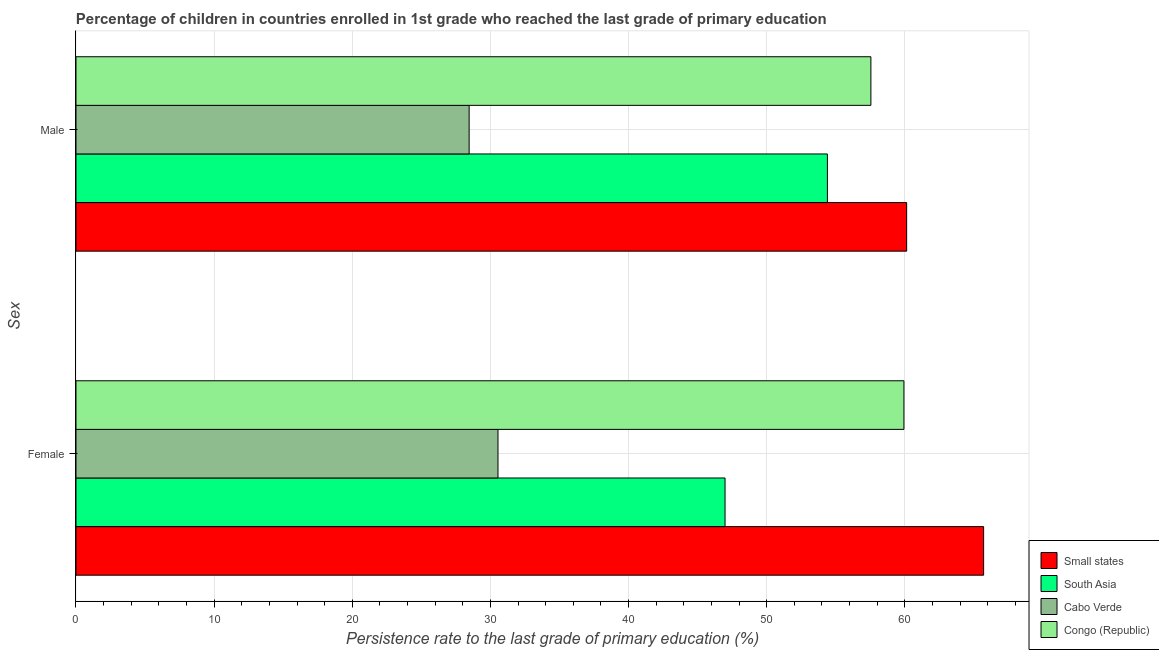Are the number of bars per tick equal to the number of legend labels?
Your answer should be compact. Yes. What is the label of the 2nd group of bars from the top?
Give a very brief answer. Female. What is the persistence rate of female students in Small states?
Provide a short and direct response. 65.71. Across all countries, what is the maximum persistence rate of male students?
Ensure brevity in your answer.  60.14. Across all countries, what is the minimum persistence rate of female students?
Offer a terse response. 30.55. In which country was the persistence rate of male students maximum?
Your answer should be compact. Small states. In which country was the persistence rate of female students minimum?
Provide a succinct answer. Cabo Verde. What is the total persistence rate of female students in the graph?
Offer a terse response. 203.19. What is the difference between the persistence rate of male students in Congo (Republic) and that in Small states?
Provide a succinct answer. -2.59. What is the difference between the persistence rate of female students in South Asia and the persistence rate of male students in Cabo Verde?
Make the answer very short. 18.53. What is the average persistence rate of female students per country?
Your answer should be very brief. 50.8. What is the difference between the persistence rate of female students and persistence rate of male students in Cabo Verde?
Give a very brief answer. 2.09. In how many countries, is the persistence rate of male students greater than 56 %?
Offer a terse response. 2. What is the ratio of the persistence rate of female students in Cabo Verde to that in South Asia?
Keep it short and to the point. 0.65. What does the 2nd bar from the top in Female represents?
Provide a short and direct response. Cabo Verde. What does the 1st bar from the bottom in Male represents?
Offer a very short reply. Small states. How many bars are there?
Your answer should be compact. 8. What is the difference between two consecutive major ticks on the X-axis?
Keep it short and to the point. 10. Are the values on the major ticks of X-axis written in scientific E-notation?
Give a very brief answer. No. How many legend labels are there?
Offer a terse response. 4. How are the legend labels stacked?
Give a very brief answer. Vertical. What is the title of the graph?
Give a very brief answer. Percentage of children in countries enrolled in 1st grade who reached the last grade of primary education. What is the label or title of the X-axis?
Offer a very short reply. Persistence rate to the last grade of primary education (%). What is the label or title of the Y-axis?
Offer a very short reply. Sex. What is the Persistence rate to the last grade of primary education (%) of Small states in Female?
Offer a terse response. 65.71. What is the Persistence rate to the last grade of primary education (%) in South Asia in Female?
Provide a succinct answer. 46.99. What is the Persistence rate to the last grade of primary education (%) in Cabo Verde in Female?
Give a very brief answer. 30.55. What is the Persistence rate to the last grade of primary education (%) of Congo (Republic) in Female?
Give a very brief answer. 59.94. What is the Persistence rate to the last grade of primary education (%) in Small states in Male?
Your answer should be very brief. 60.14. What is the Persistence rate to the last grade of primary education (%) in South Asia in Male?
Offer a terse response. 54.4. What is the Persistence rate to the last grade of primary education (%) in Cabo Verde in Male?
Provide a succinct answer. 28.46. What is the Persistence rate to the last grade of primary education (%) in Congo (Republic) in Male?
Your response must be concise. 57.55. Across all Sex, what is the maximum Persistence rate to the last grade of primary education (%) of Small states?
Keep it short and to the point. 65.71. Across all Sex, what is the maximum Persistence rate to the last grade of primary education (%) in South Asia?
Your response must be concise. 54.4. Across all Sex, what is the maximum Persistence rate to the last grade of primary education (%) of Cabo Verde?
Provide a succinct answer. 30.55. Across all Sex, what is the maximum Persistence rate to the last grade of primary education (%) in Congo (Republic)?
Ensure brevity in your answer.  59.94. Across all Sex, what is the minimum Persistence rate to the last grade of primary education (%) of Small states?
Make the answer very short. 60.14. Across all Sex, what is the minimum Persistence rate to the last grade of primary education (%) of South Asia?
Make the answer very short. 46.99. Across all Sex, what is the minimum Persistence rate to the last grade of primary education (%) in Cabo Verde?
Offer a terse response. 28.46. Across all Sex, what is the minimum Persistence rate to the last grade of primary education (%) in Congo (Republic)?
Your response must be concise. 57.55. What is the total Persistence rate to the last grade of primary education (%) of Small states in the graph?
Ensure brevity in your answer.  125.85. What is the total Persistence rate to the last grade of primary education (%) of South Asia in the graph?
Keep it short and to the point. 101.39. What is the total Persistence rate to the last grade of primary education (%) of Cabo Verde in the graph?
Provide a short and direct response. 59.01. What is the total Persistence rate to the last grade of primary education (%) in Congo (Republic) in the graph?
Offer a very short reply. 117.49. What is the difference between the Persistence rate to the last grade of primary education (%) in Small states in Female and that in Male?
Offer a terse response. 5.57. What is the difference between the Persistence rate to the last grade of primary education (%) of South Asia in Female and that in Male?
Keep it short and to the point. -7.41. What is the difference between the Persistence rate to the last grade of primary education (%) in Cabo Verde in Female and that in Male?
Your answer should be compact. 2.09. What is the difference between the Persistence rate to the last grade of primary education (%) of Congo (Republic) in Female and that in Male?
Make the answer very short. 2.39. What is the difference between the Persistence rate to the last grade of primary education (%) of Small states in Female and the Persistence rate to the last grade of primary education (%) of South Asia in Male?
Offer a very short reply. 11.31. What is the difference between the Persistence rate to the last grade of primary education (%) in Small states in Female and the Persistence rate to the last grade of primary education (%) in Cabo Verde in Male?
Offer a very short reply. 37.25. What is the difference between the Persistence rate to the last grade of primary education (%) of Small states in Female and the Persistence rate to the last grade of primary education (%) of Congo (Republic) in Male?
Your answer should be compact. 8.16. What is the difference between the Persistence rate to the last grade of primary education (%) of South Asia in Female and the Persistence rate to the last grade of primary education (%) of Cabo Verde in Male?
Provide a succinct answer. 18.53. What is the difference between the Persistence rate to the last grade of primary education (%) in South Asia in Female and the Persistence rate to the last grade of primary education (%) in Congo (Republic) in Male?
Offer a terse response. -10.56. What is the difference between the Persistence rate to the last grade of primary education (%) of Cabo Verde in Female and the Persistence rate to the last grade of primary education (%) of Congo (Republic) in Male?
Offer a terse response. -27. What is the average Persistence rate to the last grade of primary education (%) of Small states per Sex?
Make the answer very short. 62.92. What is the average Persistence rate to the last grade of primary education (%) of South Asia per Sex?
Ensure brevity in your answer.  50.7. What is the average Persistence rate to the last grade of primary education (%) of Cabo Verde per Sex?
Your answer should be very brief. 29.51. What is the average Persistence rate to the last grade of primary education (%) in Congo (Republic) per Sex?
Provide a short and direct response. 58.74. What is the difference between the Persistence rate to the last grade of primary education (%) in Small states and Persistence rate to the last grade of primary education (%) in South Asia in Female?
Keep it short and to the point. 18.72. What is the difference between the Persistence rate to the last grade of primary education (%) of Small states and Persistence rate to the last grade of primary education (%) of Cabo Verde in Female?
Ensure brevity in your answer.  35.16. What is the difference between the Persistence rate to the last grade of primary education (%) in Small states and Persistence rate to the last grade of primary education (%) in Congo (Republic) in Female?
Ensure brevity in your answer.  5.77. What is the difference between the Persistence rate to the last grade of primary education (%) in South Asia and Persistence rate to the last grade of primary education (%) in Cabo Verde in Female?
Offer a very short reply. 16.44. What is the difference between the Persistence rate to the last grade of primary education (%) in South Asia and Persistence rate to the last grade of primary education (%) in Congo (Republic) in Female?
Offer a terse response. -12.95. What is the difference between the Persistence rate to the last grade of primary education (%) of Cabo Verde and Persistence rate to the last grade of primary education (%) of Congo (Republic) in Female?
Offer a very short reply. -29.39. What is the difference between the Persistence rate to the last grade of primary education (%) in Small states and Persistence rate to the last grade of primary education (%) in South Asia in Male?
Keep it short and to the point. 5.74. What is the difference between the Persistence rate to the last grade of primary education (%) of Small states and Persistence rate to the last grade of primary education (%) of Cabo Verde in Male?
Ensure brevity in your answer.  31.68. What is the difference between the Persistence rate to the last grade of primary education (%) of Small states and Persistence rate to the last grade of primary education (%) of Congo (Republic) in Male?
Offer a very short reply. 2.59. What is the difference between the Persistence rate to the last grade of primary education (%) in South Asia and Persistence rate to the last grade of primary education (%) in Cabo Verde in Male?
Your response must be concise. 25.94. What is the difference between the Persistence rate to the last grade of primary education (%) of South Asia and Persistence rate to the last grade of primary education (%) of Congo (Republic) in Male?
Provide a short and direct response. -3.15. What is the difference between the Persistence rate to the last grade of primary education (%) of Cabo Verde and Persistence rate to the last grade of primary education (%) of Congo (Republic) in Male?
Keep it short and to the point. -29.09. What is the ratio of the Persistence rate to the last grade of primary education (%) of Small states in Female to that in Male?
Give a very brief answer. 1.09. What is the ratio of the Persistence rate to the last grade of primary education (%) in South Asia in Female to that in Male?
Offer a terse response. 0.86. What is the ratio of the Persistence rate to the last grade of primary education (%) of Cabo Verde in Female to that in Male?
Offer a terse response. 1.07. What is the ratio of the Persistence rate to the last grade of primary education (%) of Congo (Republic) in Female to that in Male?
Provide a succinct answer. 1.04. What is the difference between the highest and the second highest Persistence rate to the last grade of primary education (%) in Small states?
Your answer should be very brief. 5.57. What is the difference between the highest and the second highest Persistence rate to the last grade of primary education (%) in South Asia?
Keep it short and to the point. 7.41. What is the difference between the highest and the second highest Persistence rate to the last grade of primary education (%) of Cabo Verde?
Provide a short and direct response. 2.09. What is the difference between the highest and the second highest Persistence rate to the last grade of primary education (%) in Congo (Republic)?
Give a very brief answer. 2.39. What is the difference between the highest and the lowest Persistence rate to the last grade of primary education (%) in Small states?
Your answer should be very brief. 5.57. What is the difference between the highest and the lowest Persistence rate to the last grade of primary education (%) of South Asia?
Give a very brief answer. 7.41. What is the difference between the highest and the lowest Persistence rate to the last grade of primary education (%) in Cabo Verde?
Your answer should be compact. 2.09. What is the difference between the highest and the lowest Persistence rate to the last grade of primary education (%) of Congo (Republic)?
Provide a succinct answer. 2.39. 